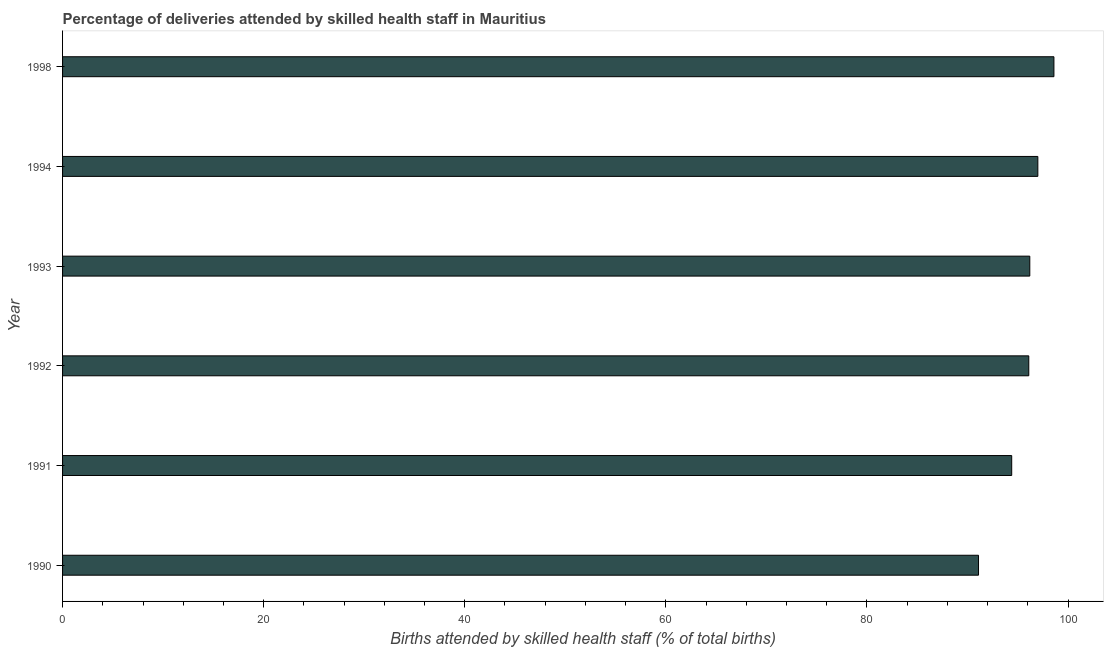Does the graph contain any zero values?
Ensure brevity in your answer.  No. Does the graph contain grids?
Provide a succinct answer. No. What is the title of the graph?
Give a very brief answer. Percentage of deliveries attended by skilled health staff in Mauritius. What is the label or title of the X-axis?
Give a very brief answer. Births attended by skilled health staff (% of total births). What is the number of births attended by skilled health staff in 1993?
Offer a terse response. 96.2. Across all years, what is the maximum number of births attended by skilled health staff?
Offer a terse response. 98.6. Across all years, what is the minimum number of births attended by skilled health staff?
Offer a terse response. 91.1. What is the sum of the number of births attended by skilled health staff?
Offer a very short reply. 573.4. What is the difference between the number of births attended by skilled health staff in 1993 and 1998?
Offer a very short reply. -2.4. What is the average number of births attended by skilled health staff per year?
Your answer should be very brief. 95.57. What is the median number of births attended by skilled health staff?
Give a very brief answer. 96.15. In how many years, is the number of births attended by skilled health staff greater than 88 %?
Your answer should be very brief. 6. Do a majority of the years between 1998 and 1992 (inclusive) have number of births attended by skilled health staff greater than 80 %?
Keep it short and to the point. Yes. What is the ratio of the number of births attended by skilled health staff in 1991 to that in 1993?
Your answer should be compact. 0.98. Is the number of births attended by skilled health staff in 1991 less than that in 1994?
Provide a succinct answer. Yes. Is the sum of the number of births attended by skilled health staff in 1990 and 1992 greater than the maximum number of births attended by skilled health staff across all years?
Make the answer very short. Yes. In how many years, is the number of births attended by skilled health staff greater than the average number of births attended by skilled health staff taken over all years?
Give a very brief answer. 4. How many bars are there?
Your answer should be very brief. 6. How many years are there in the graph?
Provide a short and direct response. 6. What is the difference between two consecutive major ticks on the X-axis?
Provide a short and direct response. 20. Are the values on the major ticks of X-axis written in scientific E-notation?
Your answer should be very brief. No. What is the Births attended by skilled health staff (% of total births) of 1990?
Offer a very short reply. 91.1. What is the Births attended by skilled health staff (% of total births) of 1991?
Give a very brief answer. 94.4. What is the Births attended by skilled health staff (% of total births) in 1992?
Provide a succinct answer. 96.1. What is the Births attended by skilled health staff (% of total births) in 1993?
Your response must be concise. 96.2. What is the Births attended by skilled health staff (% of total births) of 1994?
Provide a short and direct response. 97. What is the Births attended by skilled health staff (% of total births) of 1998?
Your answer should be compact. 98.6. What is the difference between the Births attended by skilled health staff (% of total births) in 1990 and 1994?
Keep it short and to the point. -5.9. What is the difference between the Births attended by skilled health staff (% of total births) in 1990 and 1998?
Provide a short and direct response. -7.5. What is the difference between the Births attended by skilled health staff (% of total births) in 1991 and 1992?
Give a very brief answer. -1.7. What is the difference between the Births attended by skilled health staff (% of total births) in 1991 and 1994?
Your answer should be compact. -2.6. What is the difference between the Births attended by skilled health staff (% of total births) in 1993 and 1998?
Your answer should be very brief. -2.4. What is the ratio of the Births attended by skilled health staff (% of total births) in 1990 to that in 1991?
Ensure brevity in your answer.  0.96. What is the ratio of the Births attended by skilled health staff (% of total births) in 1990 to that in 1992?
Provide a short and direct response. 0.95. What is the ratio of the Births attended by skilled health staff (% of total births) in 1990 to that in 1993?
Keep it short and to the point. 0.95. What is the ratio of the Births attended by skilled health staff (% of total births) in 1990 to that in 1994?
Keep it short and to the point. 0.94. What is the ratio of the Births attended by skilled health staff (% of total births) in 1990 to that in 1998?
Your answer should be compact. 0.92. What is the ratio of the Births attended by skilled health staff (% of total births) in 1991 to that in 1993?
Give a very brief answer. 0.98. What is the ratio of the Births attended by skilled health staff (% of total births) in 1991 to that in 1994?
Your answer should be very brief. 0.97. What is the ratio of the Births attended by skilled health staff (% of total births) in 1991 to that in 1998?
Your response must be concise. 0.96. What is the ratio of the Births attended by skilled health staff (% of total births) in 1992 to that in 1998?
Keep it short and to the point. 0.97. What is the ratio of the Births attended by skilled health staff (% of total births) in 1993 to that in 1998?
Offer a terse response. 0.98. 